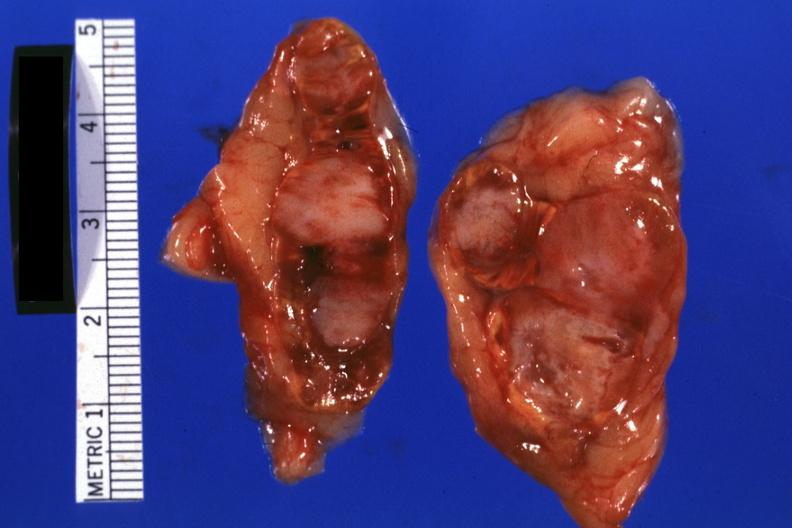what is present?
Answer the question using a single word or phrase. Endocrine 